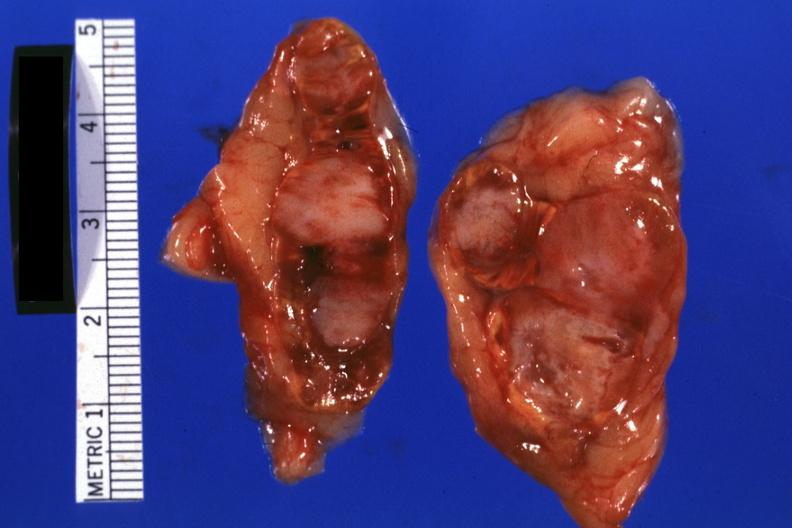what is present?
Answer the question using a single word or phrase. Endocrine 